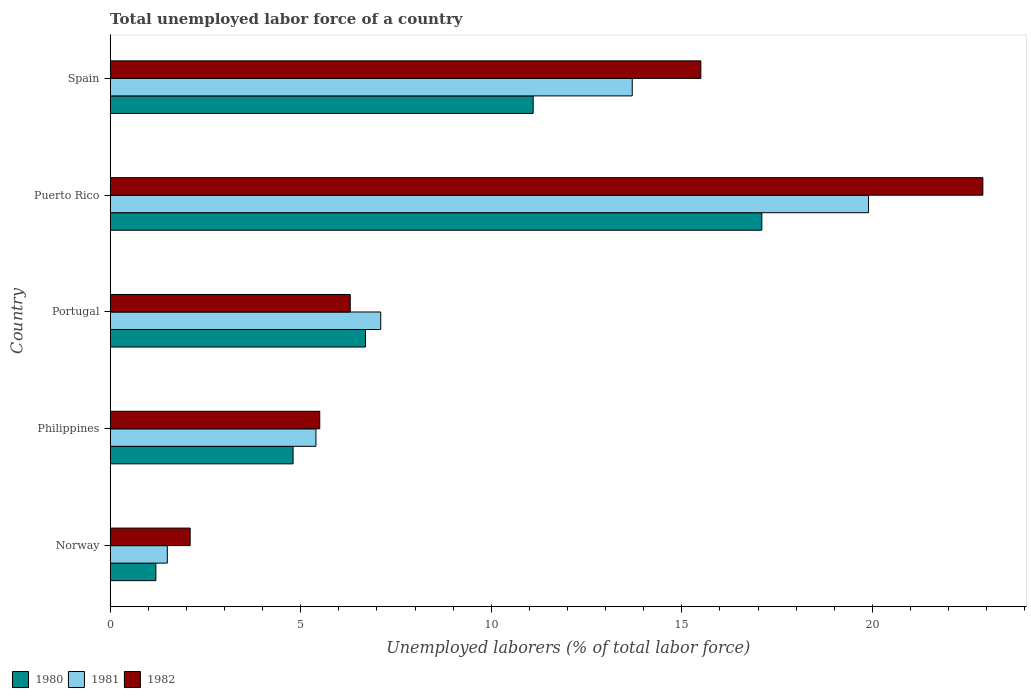Are the number of bars on each tick of the Y-axis equal?
Keep it short and to the point. Yes. How many bars are there on the 2nd tick from the top?
Provide a succinct answer. 3. What is the total unemployed labor force in 1982 in Puerto Rico?
Your answer should be compact. 22.9. Across all countries, what is the maximum total unemployed labor force in 1980?
Your answer should be compact. 17.1. In which country was the total unemployed labor force in 1980 maximum?
Ensure brevity in your answer.  Puerto Rico. In which country was the total unemployed labor force in 1980 minimum?
Your answer should be compact. Norway. What is the total total unemployed labor force in 1981 in the graph?
Your answer should be very brief. 47.6. What is the difference between the total unemployed labor force in 1982 in Philippines and that in Portugal?
Give a very brief answer. -0.8. What is the difference between the total unemployed labor force in 1980 in Norway and the total unemployed labor force in 1981 in Portugal?
Give a very brief answer. -5.9. What is the average total unemployed labor force in 1981 per country?
Give a very brief answer. 9.52. What is the difference between the total unemployed labor force in 1980 and total unemployed labor force in 1982 in Portugal?
Make the answer very short. 0.4. What is the ratio of the total unemployed labor force in 1982 in Philippines to that in Spain?
Provide a short and direct response. 0.35. Is the difference between the total unemployed labor force in 1980 in Norway and Spain greater than the difference between the total unemployed labor force in 1982 in Norway and Spain?
Your response must be concise. Yes. What is the difference between the highest and the second highest total unemployed labor force in 1981?
Provide a short and direct response. 6.2. What is the difference between the highest and the lowest total unemployed labor force in 1980?
Keep it short and to the point. 15.9. What does the 2nd bar from the bottom in Norway represents?
Provide a short and direct response. 1981. How many countries are there in the graph?
Offer a very short reply. 5. Where does the legend appear in the graph?
Keep it short and to the point. Bottom left. What is the title of the graph?
Keep it short and to the point. Total unemployed labor force of a country. Does "1964" appear as one of the legend labels in the graph?
Offer a very short reply. No. What is the label or title of the X-axis?
Ensure brevity in your answer.  Unemployed laborers (% of total labor force). What is the Unemployed laborers (% of total labor force) of 1980 in Norway?
Offer a very short reply. 1.2. What is the Unemployed laborers (% of total labor force) of 1981 in Norway?
Make the answer very short. 1.5. What is the Unemployed laborers (% of total labor force) in 1982 in Norway?
Make the answer very short. 2.1. What is the Unemployed laborers (% of total labor force) in 1980 in Philippines?
Your answer should be compact. 4.8. What is the Unemployed laborers (% of total labor force) in 1981 in Philippines?
Keep it short and to the point. 5.4. What is the Unemployed laborers (% of total labor force) of 1980 in Portugal?
Provide a short and direct response. 6.7. What is the Unemployed laborers (% of total labor force) of 1981 in Portugal?
Ensure brevity in your answer.  7.1. What is the Unemployed laborers (% of total labor force) in 1982 in Portugal?
Provide a short and direct response. 6.3. What is the Unemployed laborers (% of total labor force) of 1980 in Puerto Rico?
Ensure brevity in your answer.  17.1. What is the Unemployed laborers (% of total labor force) of 1981 in Puerto Rico?
Ensure brevity in your answer.  19.9. What is the Unemployed laborers (% of total labor force) in 1982 in Puerto Rico?
Offer a terse response. 22.9. What is the Unemployed laborers (% of total labor force) in 1980 in Spain?
Keep it short and to the point. 11.1. What is the Unemployed laborers (% of total labor force) in 1981 in Spain?
Make the answer very short. 13.7. Across all countries, what is the maximum Unemployed laborers (% of total labor force) of 1980?
Offer a terse response. 17.1. Across all countries, what is the maximum Unemployed laborers (% of total labor force) in 1981?
Make the answer very short. 19.9. Across all countries, what is the maximum Unemployed laborers (% of total labor force) of 1982?
Give a very brief answer. 22.9. Across all countries, what is the minimum Unemployed laborers (% of total labor force) of 1980?
Ensure brevity in your answer.  1.2. Across all countries, what is the minimum Unemployed laborers (% of total labor force) in 1981?
Offer a very short reply. 1.5. Across all countries, what is the minimum Unemployed laborers (% of total labor force) of 1982?
Ensure brevity in your answer.  2.1. What is the total Unemployed laborers (% of total labor force) in 1980 in the graph?
Your answer should be very brief. 40.9. What is the total Unemployed laborers (% of total labor force) in 1981 in the graph?
Offer a terse response. 47.6. What is the total Unemployed laborers (% of total labor force) of 1982 in the graph?
Your answer should be very brief. 52.3. What is the difference between the Unemployed laborers (% of total labor force) in 1980 in Norway and that in Philippines?
Your answer should be very brief. -3.6. What is the difference between the Unemployed laborers (% of total labor force) in 1980 in Norway and that in Portugal?
Offer a very short reply. -5.5. What is the difference between the Unemployed laborers (% of total labor force) in 1982 in Norway and that in Portugal?
Ensure brevity in your answer.  -4.2. What is the difference between the Unemployed laborers (% of total labor force) of 1980 in Norway and that in Puerto Rico?
Ensure brevity in your answer.  -15.9. What is the difference between the Unemployed laborers (% of total labor force) of 1981 in Norway and that in Puerto Rico?
Your answer should be very brief. -18.4. What is the difference between the Unemployed laborers (% of total labor force) in 1982 in Norway and that in Puerto Rico?
Your answer should be compact. -20.8. What is the difference between the Unemployed laborers (% of total labor force) in 1981 in Norway and that in Spain?
Provide a succinct answer. -12.2. What is the difference between the Unemployed laborers (% of total labor force) of 1982 in Norway and that in Spain?
Ensure brevity in your answer.  -13.4. What is the difference between the Unemployed laborers (% of total labor force) in 1981 in Philippines and that in Portugal?
Offer a terse response. -1.7. What is the difference between the Unemployed laborers (% of total labor force) of 1980 in Philippines and that in Puerto Rico?
Your answer should be very brief. -12.3. What is the difference between the Unemployed laborers (% of total labor force) in 1982 in Philippines and that in Puerto Rico?
Keep it short and to the point. -17.4. What is the difference between the Unemployed laborers (% of total labor force) in 1980 in Philippines and that in Spain?
Keep it short and to the point. -6.3. What is the difference between the Unemployed laborers (% of total labor force) in 1982 in Philippines and that in Spain?
Offer a very short reply. -10. What is the difference between the Unemployed laborers (% of total labor force) of 1982 in Portugal and that in Puerto Rico?
Offer a terse response. -16.6. What is the difference between the Unemployed laborers (% of total labor force) in 1980 in Portugal and that in Spain?
Offer a very short reply. -4.4. What is the difference between the Unemployed laborers (% of total labor force) in 1981 in Portugal and that in Spain?
Provide a succinct answer. -6.6. What is the difference between the Unemployed laborers (% of total labor force) of 1982 in Portugal and that in Spain?
Your answer should be very brief. -9.2. What is the difference between the Unemployed laborers (% of total labor force) in 1980 in Puerto Rico and that in Spain?
Make the answer very short. 6. What is the difference between the Unemployed laborers (% of total labor force) in 1981 in Puerto Rico and that in Spain?
Offer a terse response. 6.2. What is the difference between the Unemployed laborers (% of total labor force) of 1980 in Norway and the Unemployed laborers (% of total labor force) of 1981 in Philippines?
Make the answer very short. -4.2. What is the difference between the Unemployed laborers (% of total labor force) of 1980 in Norway and the Unemployed laborers (% of total labor force) of 1981 in Portugal?
Provide a succinct answer. -5.9. What is the difference between the Unemployed laborers (% of total labor force) in 1980 in Norway and the Unemployed laborers (% of total labor force) in 1982 in Portugal?
Your answer should be very brief. -5.1. What is the difference between the Unemployed laborers (% of total labor force) of 1980 in Norway and the Unemployed laborers (% of total labor force) of 1981 in Puerto Rico?
Keep it short and to the point. -18.7. What is the difference between the Unemployed laborers (% of total labor force) of 1980 in Norway and the Unemployed laborers (% of total labor force) of 1982 in Puerto Rico?
Ensure brevity in your answer.  -21.7. What is the difference between the Unemployed laborers (% of total labor force) in 1981 in Norway and the Unemployed laborers (% of total labor force) in 1982 in Puerto Rico?
Your answer should be very brief. -21.4. What is the difference between the Unemployed laborers (% of total labor force) in 1980 in Norway and the Unemployed laborers (% of total labor force) in 1981 in Spain?
Give a very brief answer. -12.5. What is the difference between the Unemployed laborers (% of total labor force) in 1980 in Norway and the Unemployed laborers (% of total labor force) in 1982 in Spain?
Keep it short and to the point. -14.3. What is the difference between the Unemployed laborers (% of total labor force) in 1981 in Norway and the Unemployed laborers (% of total labor force) in 1982 in Spain?
Provide a succinct answer. -14. What is the difference between the Unemployed laborers (% of total labor force) in 1980 in Philippines and the Unemployed laborers (% of total labor force) in 1982 in Portugal?
Offer a very short reply. -1.5. What is the difference between the Unemployed laborers (% of total labor force) of 1981 in Philippines and the Unemployed laborers (% of total labor force) of 1982 in Portugal?
Make the answer very short. -0.9. What is the difference between the Unemployed laborers (% of total labor force) in 1980 in Philippines and the Unemployed laborers (% of total labor force) in 1981 in Puerto Rico?
Your answer should be very brief. -15.1. What is the difference between the Unemployed laborers (% of total labor force) in 1980 in Philippines and the Unemployed laborers (% of total labor force) in 1982 in Puerto Rico?
Keep it short and to the point. -18.1. What is the difference between the Unemployed laborers (% of total labor force) of 1981 in Philippines and the Unemployed laborers (% of total labor force) of 1982 in Puerto Rico?
Make the answer very short. -17.5. What is the difference between the Unemployed laborers (% of total labor force) of 1980 in Philippines and the Unemployed laborers (% of total labor force) of 1981 in Spain?
Your response must be concise. -8.9. What is the difference between the Unemployed laborers (% of total labor force) in 1980 in Philippines and the Unemployed laborers (% of total labor force) in 1982 in Spain?
Your answer should be compact. -10.7. What is the difference between the Unemployed laborers (% of total labor force) of 1981 in Philippines and the Unemployed laborers (% of total labor force) of 1982 in Spain?
Give a very brief answer. -10.1. What is the difference between the Unemployed laborers (% of total labor force) in 1980 in Portugal and the Unemployed laborers (% of total labor force) in 1981 in Puerto Rico?
Provide a succinct answer. -13.2. What is the difference between the Unemployed laborers (% of total labor force) of 1980 in Portugal and the Unemployed laborers (% of total labor force) of 1982 in Puerto Rico?
Give a very brief answer. -16.2. What is the difference between the Unemployed laborers (% of total labor force) in 1981 in Portugal and the Unemployed laborers (% of total labor force) in 1982 in Puerto Rico?
Provide a short and direct response. -15.8. What is the difference between the Unemployed laborers (% of total labor force) of 1980 in Portugal and the Unemployed laborers (% of total labor force) of 1982 in Spain?
Give a very brief answer. -8.8. What is the difference between the Unemployed laborers (% of total labor force) in 1980 in Puerto Rico and the Unemployed laborers (% of total labor force) in 1982 in Spain?
Your answer should be compact. 1.6. What is the difference between the Unemployed laborers (% of total labor force) of 1981 in Puerto Rico and the Unemployed laborers (% of total labor force) of 1982 in Spain?
Provide a short and direct response. 4.4. What is the average Unemployed laborers (% of total labor force) of 1980 per country?
Offer a terse response. 8.18. What is the average Unemployed laborers (% of total labor force) in 1981 per country?
Keep it short and to the point. 9.52. What is the average Unemployed laborers (% of total labor force) in 1982 per country?
Your response must be concise. 10.46. What is the difference between the Unemployed laborers (% of total labor force) in 1980 and Unemployed laborers (% of total labor force) in 1981 in Norway?
Provide a succinct answer. -0.3. What is the difference between the Unemployed laborers (% of total labor force) in 1980 and Unemployed laborers (% of total labor force) in 1982 in Norway?
Your response must be concise. -0.9. What is the difference between the Unemployed laborers (% of total labor force) of 1981 and Unemployed laborers (% of total labor force) of 1982 in Norway?
Ensure brevity in your answer.  -0.6. What is the difference between the Unemployed laborers (% of total labor force) in 1980 and Unemployed laborers (% of total labor force) in 1981 in Philippines?
Your answer should be compact. -0.6. What is the difference between the Unemployed laborers (% of total labor force) of 1980 and Unemployed laborers (% of total labor force) of 1981 in Portugal?
Give a very brief answer. -0.4. What is the difference between the Unemployed laborers (% of total labor force) in 1980 and Unemployed laborers (% of total labor force) in 1981 in Puerto Rico?
Ensure brevity in your answer.  -2.8. What is the difference between the Unemployed laborers (% of total labor force) in 1981 and Unemployed laborers (% of total labor force) in 1982 in Puerto Rico?
Your answer should be very brief. -3. What is the ratio of the Unemployed laborers (% of total labor force) of 1980 in Norway to that in Philippines?
Make the answer very short. 0.25. What is the ratio of the Unemployed laborers (% of total labor force) in 1981 in Norway to that in Philippines?
Your answer should be compact. 0.28. What is the ratio of the Unemployed laborers (% of total labor force) in 1982 in Norway to that in Philippines?
Your answer should be compact. 0.38. What is the ratio of the Unemployed laborers (% of total labor force) of 1980 in Norway to that in Portugal?
Your answer should be compact. 0.18. What is the ratio of the Unemployed laborers (% of total labor force) of 1981 in Norway to that in Portugal?
Ensure brevity in your answer.  0.21. What is the ratio of the Unemployed laborers (% of total labor force) in 1982 in Norway to that in Portugal?
Provide a short and direct response. 0.33. What is the ratio of the Unemployed laborers (% of total labor force) in 1980 in Norway to that in Puerto Rico?
Provide a succinct answer. 0.07. What is the ratio of the Unemployed laborers (% of total labor force) of 1981 in Norway to that in Puerto Rico?
Offer a very short reply. 0.08. What is the ratio of the Unemployed laborers (% of total labor force) of 1982 in Norway to that in Puerto Rico?
Make the answer very short. 0.09. What is the ratio of the Unemployed laborers (% of total labor force) of 1980 in Norway to that in Spain?
Ensure brevity in your answer.  0.11. What is the ratio of the Unemployed laborers (% of total labor force) in 1981 in Norway to that in Spain?
Offer a very short reply. 0.11. What is the ratio of the Unemployed laborers (% of total labor force) of 1982 in Norway to that in Spain?
Ensure brevity in your answer.  0.14. What is the ratio of the Unemployed laborers (% of total labor force) of 1980 in Philippines to that in Portugal?
Provide a succinct answer. 0.72. What is the ratio of the Unemployed laborers (% of total labor force) of 1981 in Philippines to that in Portugal?
Keep it short and to the point. 0.76. What is the ratio of the Unemployed laborers (% of total labor force) of 1982 in Philippines to that in Portugal?
Provide a short and direct response. 0.87. What is the ratio of the Unemployed laborers (% of total labor force) of 1980 in Philippines to that in Puerto Rico?
Ensure brevity in your answer.  0.28. What is the ratio of the Unemployed laborers (% of total labor force) of 1981 in Philippines to that in Puerto Rico?
Offer a very short reply. 0.27. What is the ratio of the Unemployed laborers (% of total labor force) in 1982 in Philippines to that in Puerto Rico?
Make the answer very short. 0.24. What is the ratio of the Unemployed laborers (% of total labor force) of 1980 in Philippines to that in Spain?
Provide a short and direct response. 0.43. What is the ratio of the Unemployed laborers (% of total labor force) in 1981 in Philippines to that in Spain?
Your answer should be very brief. 0.39. What is the ratio of the Unemployed laborers (% of total labor force) of 1982 in Philippines to that in Spain?
Offer a terse response. 0.35. What is the ratio of the Unemployed laborers (% of total labor force) of 1980 in Portugal to that in Puerto Rico?
Offer a very short reply. 0.39. What is the ratio of the Unemployed laborers (% of total labor force) of 1981 in Portugal to that in Puerto Rico?
Your answer should be very brief. 0.36. What is the ratio of the Unemployed laborers (% of total labor force) of 1982 in Portugal to that in Puerto Rico?
Provide a succinct answer. 0.28. What is the ratio of the Unemployed laborers (% of total labor force) of 1980 in Portugal to that in Spain?
Your answer should be very brief. 0.6. What is the ratio of the Unemployed laborers (% of total labor force) in 1981 in Portugal to that in Spain?
Keep it short and to the point. 0.52. What is the ratio of the Unemployed laborers (% of total labor force) in 1982 in Portugal to that in Spain?
Provide a short and direct response. 0.41. What is the ratio of the Unemployed laborers (% of total labor force) of 1980 in Puerto Rico to that in Spain?
Ensure brevity in your answer.  1.54. What is the ratio of the Unemployed laborers (% of total labor force) in 1981 in Puerto Rico to that in Spain?
Ensure brevity in your answer.  1.45. What is the ratio of the Unemployed laborers (% of total labor force) of 1982 in Puerto Rico to that in Spain?
Provide a succinct answer. 1.48. What is the difference between the highest and the second highest Unemployed laborers (% of total labor force) in 1980?
Provide a succinct answer. 6. What is the difference between the highest and the lowest Unemployed laborers (% of total labor force) in 1982?
Give a very brief answer. 20.8. 